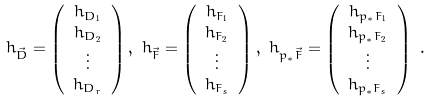<formula> <loc_0><loc_0><loc_500><loc_500>& { h } _ { \vec { D } } = \left ( \begin{array} { c } h _ { D _ { 1 } } \\ h _ { D _ { 2 } } \\ \vdots \\ h _ { D _ { r } } \end{array} \right ) , \ { h } _ { \vec { F } } = \left ( \begin{array} { c } h _ { F _ { 1 } } \\ h _ { F _ { 2 } } \\ \vdots \\ h _ { F _ { s } } \end{array} \right ) , \ { h } _ { { p } _ { * } \vec { F } } = \left ( \begin{array} { c } h _ { { p } _ { * } F _ { 1 } } \\ h _ { { p } _ { * } F _ { 2 } } \\ \vdots \\ h _ { { p } _ { * } F _ { s } } \end{array} \right ) \ .</formula> 